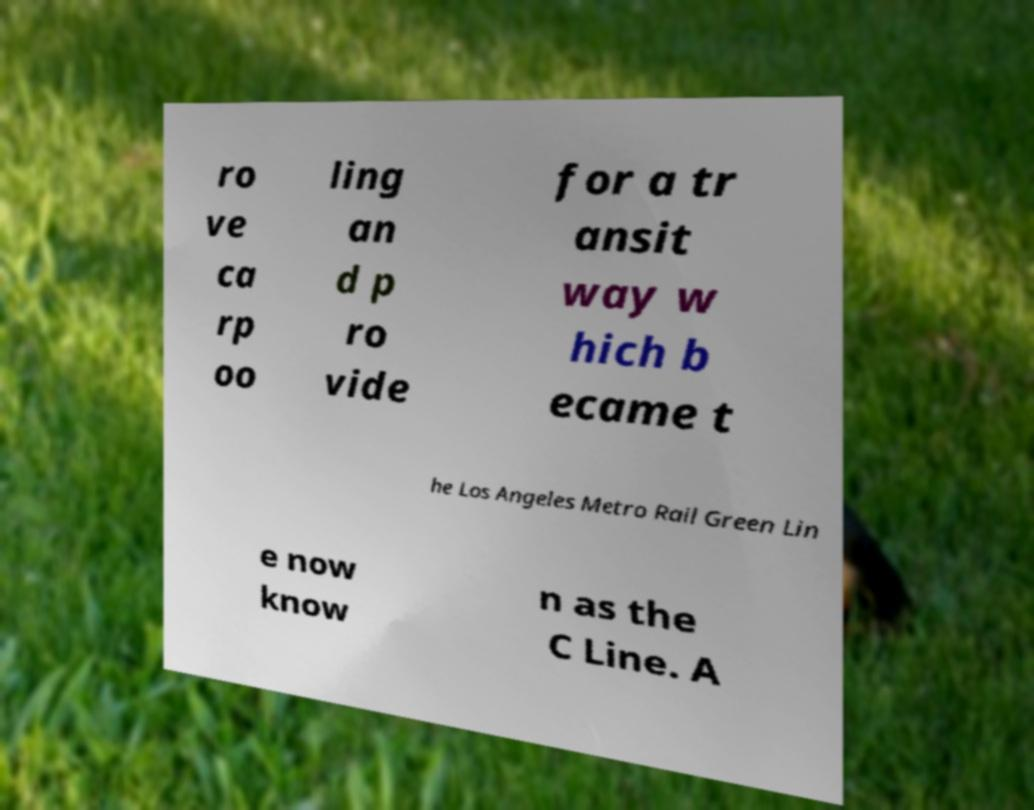I need the written content from this picture converted into text. Can you do that? ro ve ca rp oo ling an d p ro vide for a tr ansit way w hich b ecame t he Los Angeles Metro Rail Green Lin e now know n as the C Line. A 